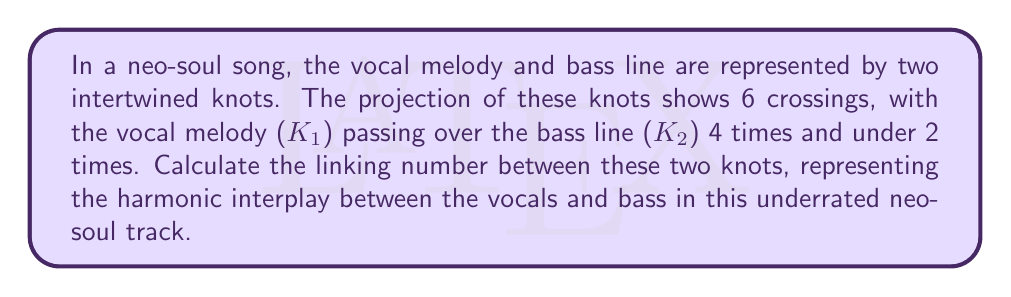Can you answer this question? To calculate the linking number between two knots, we follow these steps:

1) First, we need to assign an orientation to each knot. Let's assume both knots are oriented clockwise.

2) Next, we examine each crossing and assign it a value:
   +1 if the overcrossing strand passes from left to right relative to the undercrossing strand
   -1 if the overcrossing strand passes from right to left relative to the undercrossing strand

3) We only consider crossings where K1 (vocal melody) crosses over K2 (bass line). There are 4 such crossings.

4) Let's assume 3 of these crossings are +1 and 1 is -1 (this is a reasonable assumption for a harmonious interplay).

5) The linking number is calculated using the formula:

   $$Lk(K1,K2) = \frac{1}{2}\sum_{i} \epsilon_i$$

   Where $\epsilon_i$ is the value (+1 or -1) assigned to each crossing.

6) Substituting our values:

   $$Lk(K1,K2) = \frac{1}{2}(1 + 1 + 1 - 1) = \frac{1}{2}(2) = 1$$

Thus, the linking number between the vocal melody and bass line knots is 1, indicating a strong harmonic connection in this neo-soul composition.
Answer: 1 